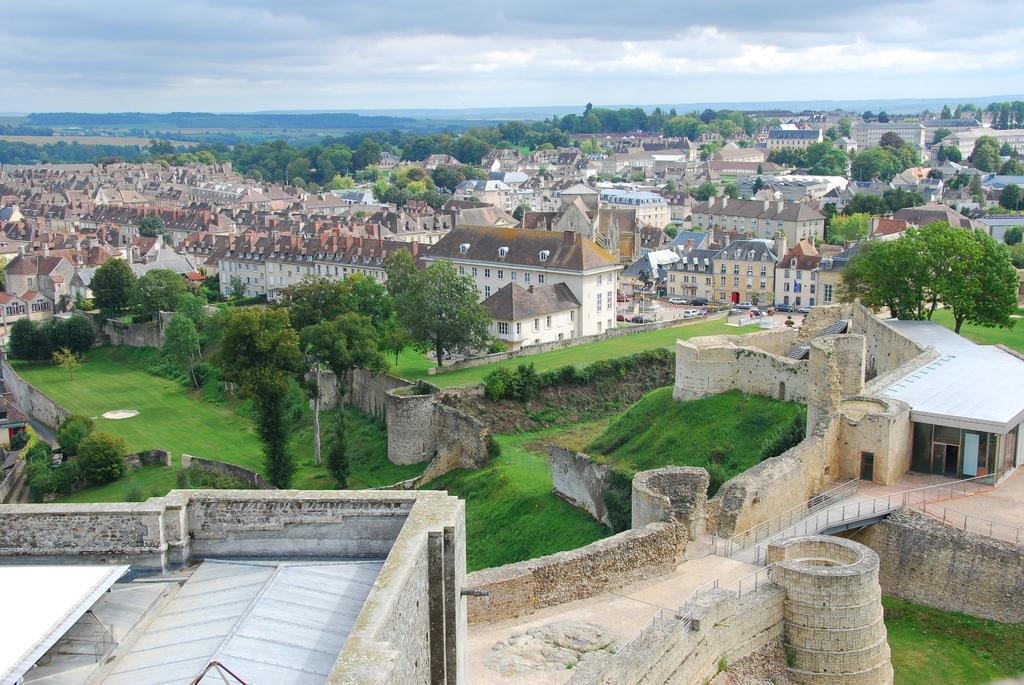What types of structures are visible in the image? There are multiple buildings in the image. What else can be seen between the buildings? Trees and plants are present between the buildings. What is visible in the background of the image? The sky is visible in the background of the image. Can you hear the buildings talking to each other in the image? There is no sound or communication between the buildings in the image, as it is a still image. 